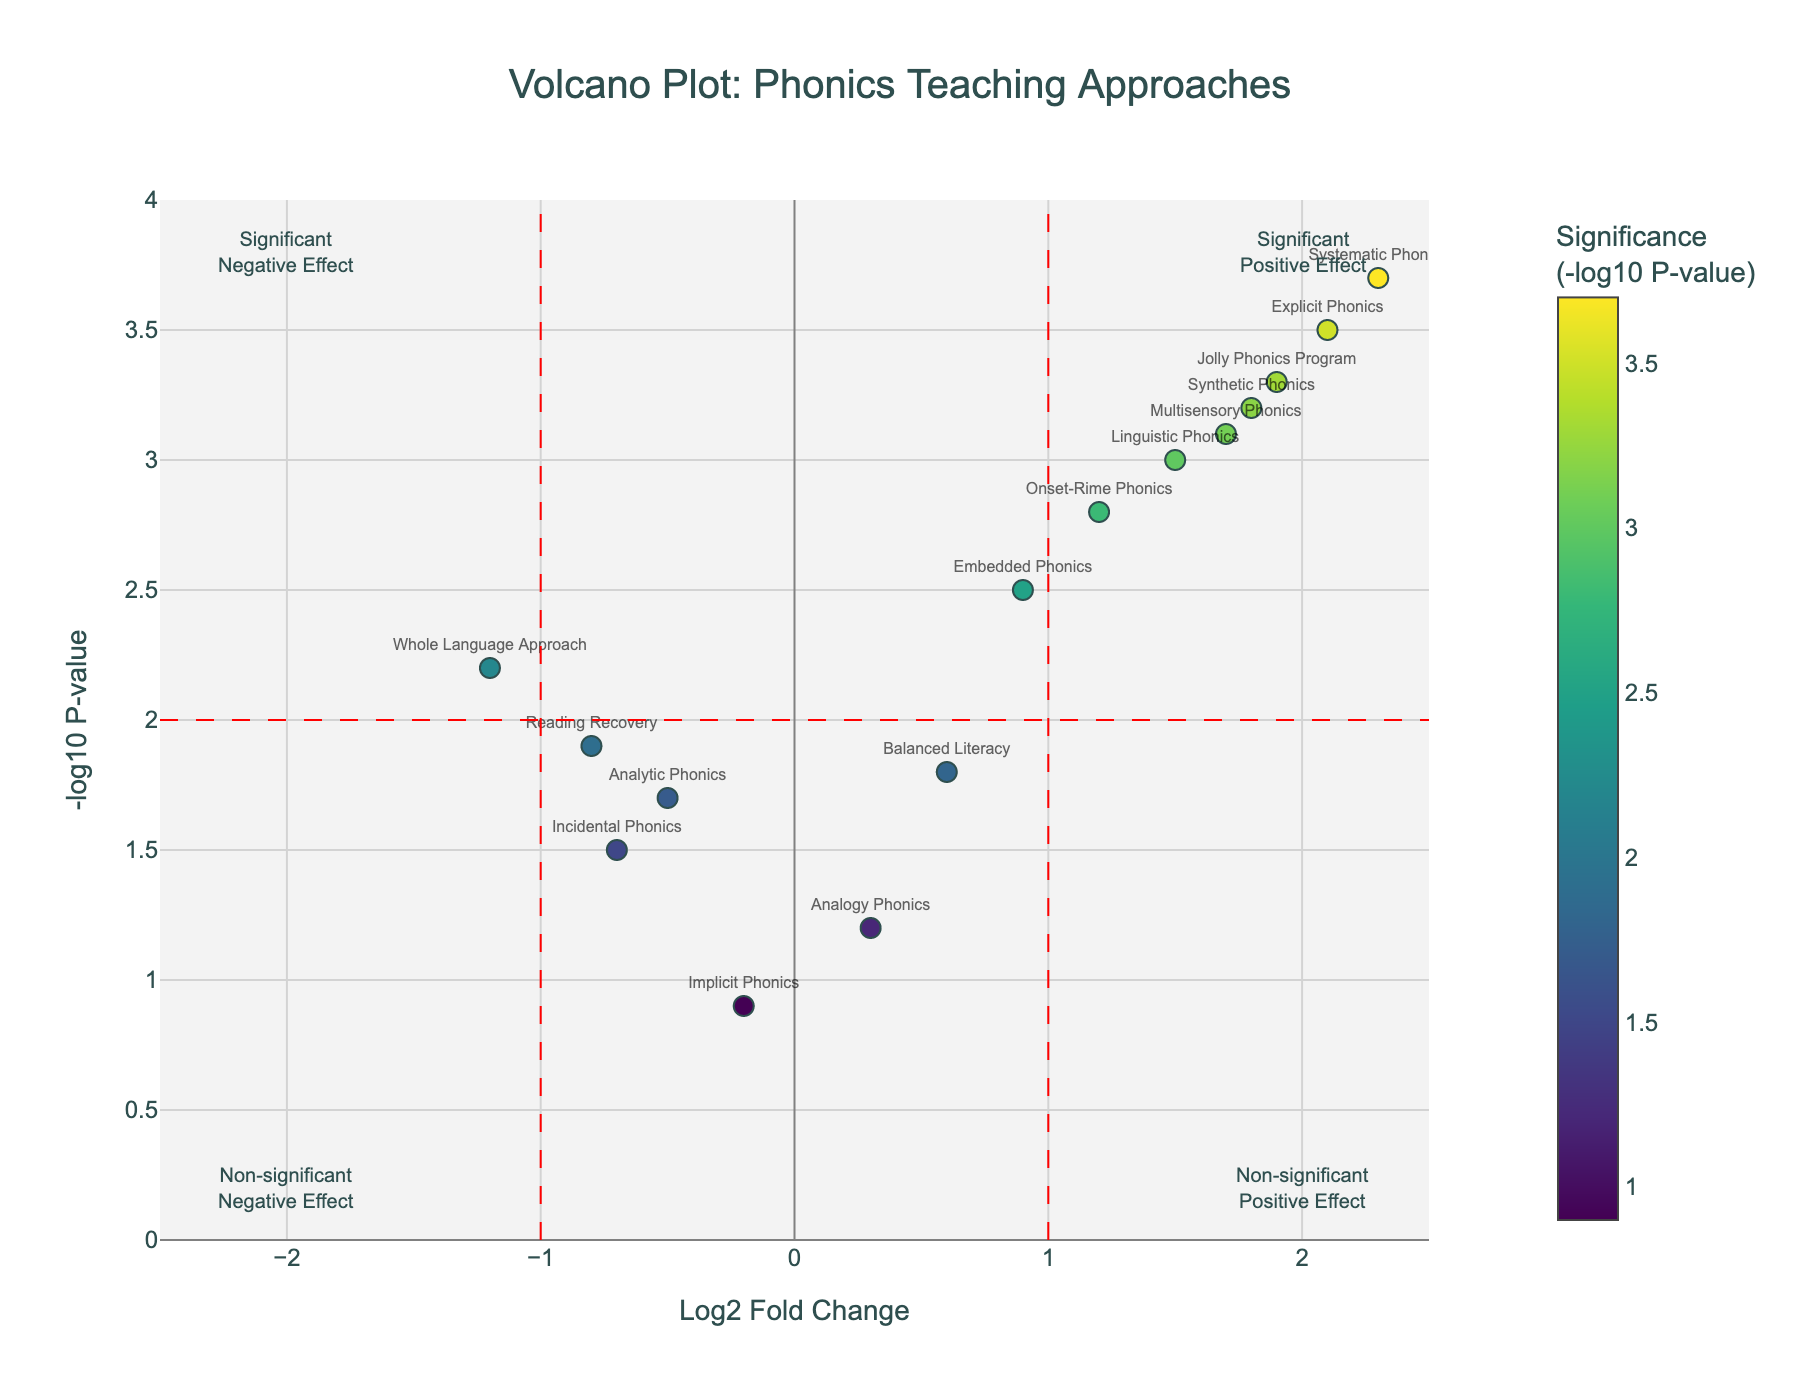What's the title of the figure? The title of the figure is displayed at the top center. It is used to describe the content of the plot.
Answer: Volcano Plot: Phonics Teaching Approaches How many teaching approaches have both a Log2 Fold Change greater than 1 and a Negative Log10 P-value greater than 2? To find the number of teaching approaches that satisfy both conditions, count the points in the top-right quadrant (positive Log2 Fold Change and high significance).
Answer: 6 Which teaching method has the highest Log2 Fold Change? Look at the data points in the plot and identify the point with the maximum x-axis value (Log2 Fold Change).
Answer: Systematic Phonics Are there any methods with a negative Log2 Fold Change and a Negative Log10 P-value less than 2? Identify the data points in the bottom-left quadrant (negative Log2 Fold Change and low significance).
Answer: Yes, Analytic Phonics and Implicit Phonics Which method shows a significant negative effect? A significant negative effect is indicated by a data point in the top-left quadrant (negative Log2 Fold Change and high significance).
Answer: Whole Language Approach Compare the significance of the Synthetic Phonics and Jolly Phonics Program. Which one is more significant? Compare the y-axis (Negative Log10 P-value) values of Synthetic Phonics and Jolly Phonics Program. The higher y-axis value indicates greater significance.
Answer: Jolly Phonics Program What is the difference in Log2 Fold Change between the Systematic Phonics and the Balanced Literacy approach? Subtract the Log2 Fold Change of Balanced Literacy from that of Systematic Phonics. (2.3 - 0.6 = 1.7)
Answer: 1.7 Which approach has the lowest significance according to the Negative Log10 P-value? Find the point with the lowest y-axis value (Negative Log10 P-value) in the plot.
Answer: Implicit Phonics How many teaching methods have a non-significant positive effect? Count the points in the bottom-right quadrant (positive Log2 Fold Change and low significance).
Answer: 2 